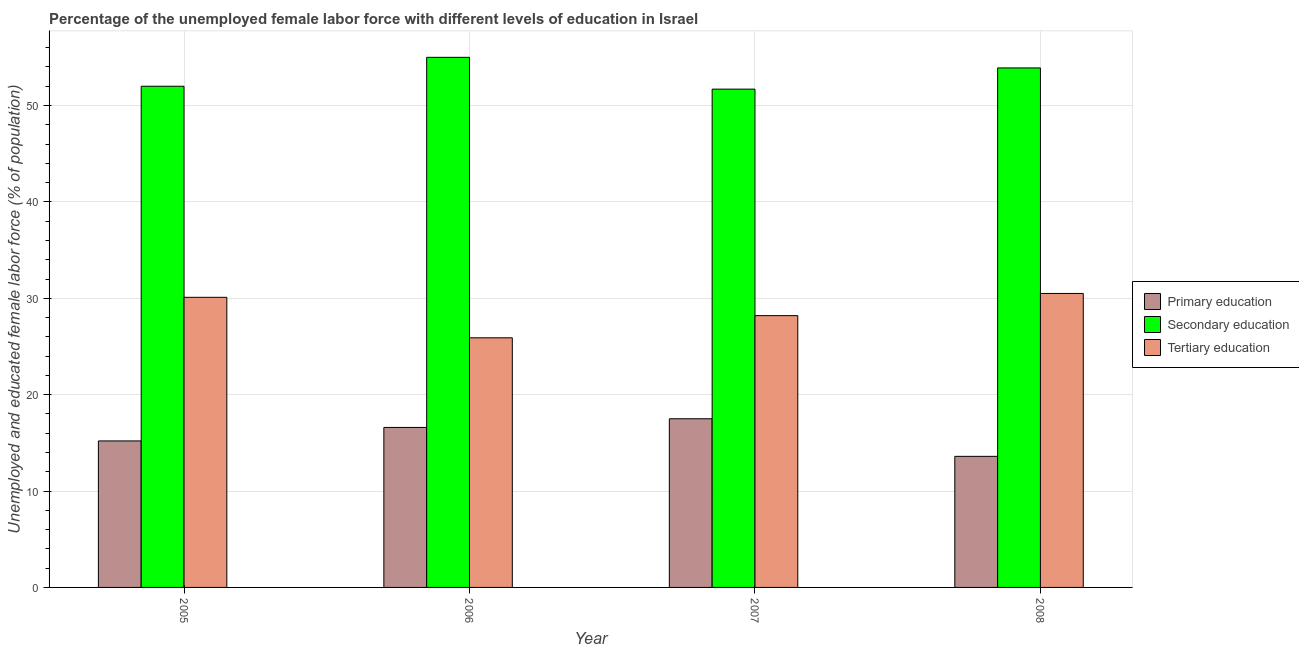Are the number of bars per tick equal to the number of legend labels?
Ensure brevity in your answer.  Yes. What is the label of the 2nd group of bars from the left?
Ensure brevity in your answer.  2006. What is the percentage of female labor force who received primary education in 2006?
Keep it short and to the point. 16.6. Across all years, what is the maximum percentage of female labor force who received tertiary education?
Offer a very short reply. 30.5. Across all years, what is the minimum percentage of female labor force who received tertiary education?
Your response must be concise. 25.9. What is the total percentage of female labor force who received primary education in the graph?
Provide a short and direct response. 62.9. What is the difference between the percentage of female labor force who received secondary education in 2006 and that in 2007?
Provide a succinct answer. 3.3. What is the difference between the percentage of female labor force who received secondary education in 2008 and the percentage of female labor force who received tertiary education in 2005?
Give a very brief answer. 1.9. What is the average percentage of female labor force who received tertiary education per year?
Make the answer very short. 28.68. What is the ratio of the percentage of female labor force who received secondary education in 2005 to that in 2008?
Your answer should be very brief. 0.96. Is the percentage of female labor force who received tertiary education in 2007 less than that in 2008?
Provide a short and direct response. Yes. What is the difference between the highest and the second highest percentage of female labor force who received tertiary education?
Provide a succinct answer. 0.4. What is the difference between the highest and the lowest percentage of female labor force who received primary education?
Give a very brief answer. 3.9. In how many years, is the percentage of female labor force who received tertiary education greater than the average percentage of female labor force who received tertiary education taken over all years?
Ensure brevity in your answer.  2. Is the sum of the percentage of female labor force who received secondary education in 2006 and 2007 greater than the maximum percentage of female labor force who received primary education across all years?
Offer a terse response. Yes. What does the 3rd bar from the right in 2008 represents?
Offer a very short reply. Primary education. How many years are there in the graph?
Provide a short and direct response. 4. What is the difference between two consecutive major ticks on the Y-axis?
Your answer should be very brief. 10. Does the graph contain any zero values?
Your answer should be very brief. No. Does the graph contain grids?
Your answer should be compact. Yes. How are the legend labels stacked?
Your answer should be compact. Vertical. What is the title of the graph?
Give a very brief answer. Percentage of the unemployed female labor force with different levels of education in Israel. What is the label or title of the X-axis?
Your answer should be compact. Year. What is the label or title of the Y-axis?
Provide a short and direct response. Unemployed and educated female labor force (% of population). What is the Unemployed and educated female labor force (% of population) in Primary education in 2005?
Keep it short and to the point. 15.2. What is the Unemployed and educated female labor force (% of population) of Secondary education in 2005?
Ensure brevity in your answer.  52. What is the Unemployed and educated female labor force (% of population) in Tertiary education in 2005?
Your answer should be very brief. 30.1. What is the Unemployed and educated female labor force (% of population) in Primary education in 2006?
Provide a short and direct response. 16.6. What is the Unemployed and educated female labor force (% of population) in Tertiary education in 2006?
Provide a short and direct response. 25.9. What is the Unemployed and educated female labor force (% of population) in Secondary education in 2007?
Give a very brief answer. 51.7. What is the Unemployed and educated female labor force (% of population) in Tertiary education in 2007?
Provide a short and direct response. 28.2. What is the Unemployed and educated female labor force (% of population) of Primary education in 2008?
Give a very brief answer. 13.6. What is the Unemployed and educated female labor force (% of population) of Secondary education in 2008?
Your response must be concise. 53.9. What is the Unemployed and educated female labor force (% of population) of Tertiary education in 2008?
Offer a very short reply. 30.5. Across all years, what is the maximum Unemployed and educated female labor force (% of population) in Tertiary education?
Give a very brief answer. 30.5. Across all years, what is the minimum Unemployed and educated female labor force (% of population) in Primary education?
Your response must be concise. 13.6. Across all years, what is the minimum Unemployed and educated female labor force (% of population) of Secondary education?
Your response must be concise. 51.7. Across all years, what is the minimum Unemployed and educated female labor force (% of population) in Tertiary education?
Keep it short and to the point. 25.9. What is the total Unemployed and educated female labor force (% of population) of Primary education in the graph?
Your response must be concise. 62.9. What is the total Unemployed and educated female labor force (% of population) in Secondary education in the graph?
Keep it short and to the point. 212.6. What is the total Unemployed and educated female labor force (% of population) in Tertiary education in the graph?
Keep it short and to the point. 114.7. What is the difference between the Unemployed and educated female labor force (% of population) of Primary education in 2005 and that in 2007?
Offer a very short reply. -2.3. What is the difference between the Unemployed and educated female labor force (% of population) of Secondary education in 2005 and that in 2007?
Provide a short and direct response. 0.3. What is the difference between the Unemployed and educated female labor force (% of population) of Tertiary education in 2005 and that in 2007?
Your answer should be very brief. 1.9. What is the difference between the Unemployed and educated female labor force (% of population) of Tertiary education in 2005 and that in 2008?
Keep it short and to the point. -0.4. What is the difference between the Unemployed and educated female labor force (% of population) of Tertiary education in 2006 and that in 2007?
Offer a terse response. -2.3. What is the difference between the Unemployed and educated female labor force (% of population) in Primary education in 2006 and that in 2008?
Your answer should be very brief. 3. What is the difference between the Unemployed and educated female labor force (% of population) of Secondary education in 2006 and that in 2008?
Keep it short and to the point. 1.1. What is the difference between the Unemployed and educated female labor force (% of population) of Secondary education in 2007 and that in 2008?
Keep it short and to the point. -2.2. What is the difference between the Unemployed and educated female labor force (% of population) in Primary education in 2005 and the Unemployed and educated female labor force (% of population) in Secondary education in 2006?
Keep it short and to the point. -39.8. What is the difference between the Unemployed and educated female labor force (% of population) in Secondary education in 2005 and the Unemployed and educated female labor force (% of population) in Tertiary education in 2006?
Keep it short and to the point. 26.1. What is the difference between the Unemployed and educated female labor force (% of population) of Primary education in 2005 and the Unemployed and educated female labor force (% of population) of Secondary education in 2007?
Your response must be concise. -36.5. What is the difference between the Unemployed and educated female labor force (% of population) of Secondary education in 2005 and the Unemployed and educated female labor force (% of population) of Tertiary education in 2007?
Make the answer very short. 23.8. What is the difference between the Unemployed and educated female labor force (% of population) in Primary education in 2005 and the Unemployed and educated female labor force (% of population) in Secondary education in 2008?
Offer a very short reply. -38.7. What is the difference between the Unemployed and educated female labor force (% of population) in Primary education in 2005 and the Unemployed and educated female labor force (% of population) in Tertiary education in 2008?
Offer a very short reply. -15.3. What is the difference between the Unemployed and educated female labor force (% of population) of Secondary education in 2005 and the Unemployed and educated female labor force (% of population) of Tertiary education in 2008?
Provide a short and direct response. 21.5. What is the difference between the Unemployed and educated female labor force (% of population) of Primary education in 2006 and the Unemployed and educated female labor force (% of population) of Secondary education in 2007?
Ensure brevity in your answer.  -35.1. What is the difference between the Unemployed and educated female labor force (% of population) of Primary education in 2006 and the Unemployed and educated female labor force (% of population) of Tertiary education in 2007?
Offer a very short reply. -11.6. What is the difference between the Unemployed and educated female labor force (% of population) of Secondary education in 2006 and the Unemployed and educated female labor force (% of population) of Tertiary education in 2007?
Give a very brief answer. 26.8. What is the difference between the Unemployed and educated female labor force (% of population) of Primary education in 2006 and the Unemployed and educated female labor force (% of population) of Secondary education in 2008?
Provide a short and direct response. -37.3. What is the difference between the Unemployed and educated female labor force (% of population) in Secondary education in 2006 and the Unemployed and educated female labor force (% of population) in Tertiary education in 2008?
Offer a terse response. 24.5. What is the difference between the Unemployed and educated female labor force (% of population) in Primary education in 2007 and the Unemployed and educated female labor force (% of population) in Secondary education in 2008?
Your answer should be very brief. -36.4. What is the difference between the Unemployed and educated female labor force (% of population) in Primary education in 2007 and the Unemployed and educated female labor force (% of population) in Tertiary education in 2008?
Offer a very short reply. -13. What is the difference between the Unemployed and educated female labor force (% of population) in Secondary education in 2007 and the Unemployed and educated female labor force (% of population) in Tertiary education in 2008?
Provide a short and direct response. 21.2. What is the average Unemployed and educated female labor force (% of population) of Primary education per year?
Ensure brevity in your answer.  15.72. What is the average Unemployed and educated female labor force (% of population) in Secondary education per year?
Offer a very short reply. 53.15. What is the average Unemployed and educated female labor force (% of population) of Tertiary education per year?
Give a very brief answer. 28.68. In the year 2005, what is the difference between the Unemployed and educated female labor force (% of population) in Primary education and Unemployed and educated female labor force (% of population) in Secondary education?
Offer a very short reply. -36.8. In the year 2005, what is the difference between the Unemployed and educated female labor force (% of population) of Primary education and Unemployed and educated female labor force (% of population) of Tertiary education?
Give a very brief answer. -14.9. In the year 2005, what is the difference between the Unemployed and educated female labor force (% of population) in Secondary education and Unemployed and educated female labor force (% of population) in Tertiary education?
Your response must be concise. 21.9. In the year 2006, what is the difference between the Unemployed and educated female labor force (% of population) of Primary education and Unemployed and educated female labor force (% of population) of Secondary education?
Make the answer very short. -38.4. In the year 2006, what is the difference between the Unemployed and educated female labor force (% of population) in Primary education and Unemployed and educated female labor force (% of population) in Tertiary education?
Offer a very short reply. -9.3. In the year 2006, what is the difference between the Unemployed and educated female labor force (% of population) in Secondary education and Unemployed and educated female labor force (% of population) in Tertiary education?
Give a very brief answer. 29.1. In the year 2007, what is the difference between the Unemployed and educated female labor force (% of population) in Primary education and Unemployed and educated female labor force (% of population) in Secondary education?
Provide a short and direct response. -34.2. In the year 2008, what is the difference between the Unemployed and educated female labor force (% of population) in Primary education and Unemployed and educated female labor force (% of population) in Secondary education?
Give a very brief answer. -40.3. In the year 2008, what is the difference between the Unemployed and educated female labor force (% of population) in Primary education and Unemployed and educated female labor force (% of population) in Tertiary education?
Offer a terse response. -16.9. In the year 2008, what is the difference between the Unemployed and educated female labor force (% of population) in Secondary education and Unemployed and educated female labor force (% of population) in Tertiary education?
Provide a succinct answer. 23.4. What is the ratio of the Unemployed and educated female labor force (% of population) in Primary education in 2005 to that in 2006?
Make the answer very short. 0.92. What is the ratio of the Unemployed and educated female labor force (% of population) of Secondary education in 2005 to that in 2006?
Your response must be concise. 0.95. What is the ratio of the Unemployed and educated female labor force (% of population) in Tertiary education in 2005 to that in 2006?
Your answer should be very brief. 1.16. What is the ratio of the Unemployed and educated female labor force (% of population) of Primary education in 2005 to that in 2007?
Your answer should be compact. 0.87. What is the ratio of the Unemployed and educated female labor force (% of population) in Secondary education in 2005 to that in 2007?
Provide a short and direct response. 1.01. What is the ratio of the Unemployed and educated female labor force (% of population) of Tertiary education in 2005 to that in 2007?
Ensure brevity in your answer.  1.07. What is the ratio of the Unemployed and educated female labor force (% of population) in Primary education in 2005 to that in 2008?
Provide a short and direct response. 1.12. What is the ratio of the Unemployed and educated female labor force (% of population) in Secondary education in 2005 to that in 2008?
Make the answer very short. 0.96. What is the ratio of the Unemployed and educated female labor force (% of population) in Tertiary education in 2005 to that in 2008?
Offer a terse response. 0.99. What is the ratio of the Unemployed and educated female labor force (% of population) in Primary education in 2006 to that in 2007?
Offer a terse response. 0.95. What is the ratio of the Unemployed and educated female labor force (% of population) in Secondary education in 2006 to that in 2007?
Give a very brief answer. 1.06. What is the ratio of the Unemployed and educated female labor force (% of population) of Tertiary education in 2006 to that in 2007?
Provide a succinct answer. 0.92. What is the ratio of the Unemployed and educated female labor force (% of population) of Primary education in 2006 to that in 2008?
Your answer should be very brief. 1.22. What is the ratio of the Unemployed and educated female labor force (% of population) in Secondary education in 2006 to that in 2008?
Make the answer very short. 1.02. What is the ratio of the Unemployed and educated female labor force (% of population) of Tertiary education in 2006 to that in 2008?
Offer a terse response. 0.85. What is the ratio of the Unemployed and educated female labor force (% of population) of Primary education in 2007 to that in 2008?
Keep it short and to the point. 1.29. What is the ratio of the Unemployed and educated female labor force (% of population) in Secondary education in 2007 to that in 2008?
Make the answer very short. 0.96. What is the ratio of the Unemployed and educated female labor force (% of population) in Tertiary education in 2007 to that in 2008?
Provide a succinct answer. 0.92. What is the difference between the highest and the second highest Unemployed and educated female labor force (% of population) of Primary education?
Offer a terse response. 0.9. What is the difference between the highest and the second highest Unemployed and educated female labor force (% of population) of Secondary education?
Your answer should be compact. 1.1. What is the difference between the highest and the second highest Unemployed and educated female labor force (% of population) in Tertiary education?
Provide a succinct answer. 0.4. What is the difference between the highest and the lowest Unemployed and educated female labor force (% of population) of Primary education?
Offer a terse response. 3.9. What is the difference between the highest and the lowest Unemployed and educated female labor force (% of population) of Secondary education?
Provide a succinct answer. 3.3. 